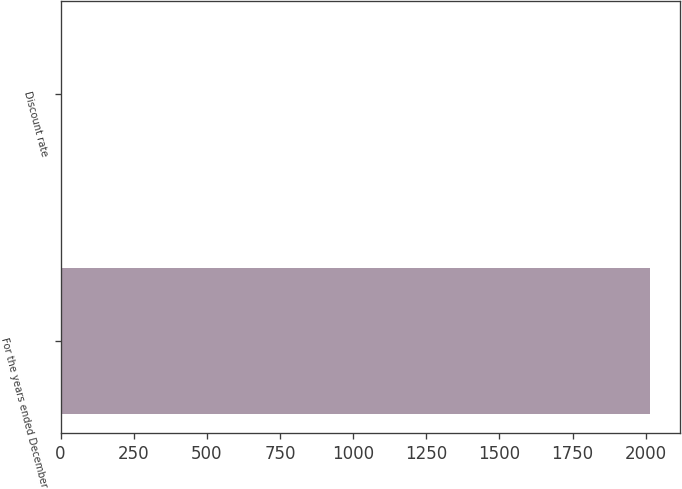Convert chart. <chart><loc_0><loc_0><loc_500><loc_500><bar_chart><fcel>For the years ended December<fcel>Discount rate<nl><fcel>2016<fcel>4<nl></chart> 